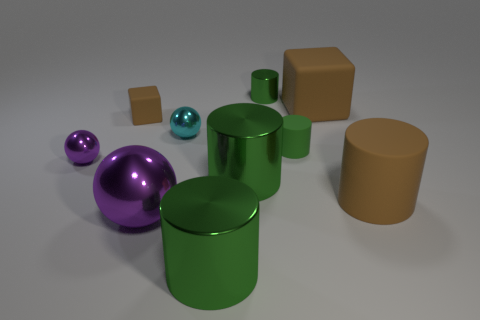How many green cylinders must be subtracted to get 1 green cylinders? 3 Subtract all gray cylinders. How many purple balls are left? 2 Subtract all small green cylinders. How many cylinders are left? 3 Subtract all brown cylinders. How many cylinders are left? 4 Subtract 1 spheres. How many spheres are left? 2 Subtract all blocks. How many objects are left? 8 Subtract all brown cylinders. Subtract all yellow balls. How many cylinders are left? 4 Subtract all tiny cyan things. Subtract all big green cylinders. How many objects are left? 7 Add 8 tiny cyan metal spheres. How many tiny cyan metal spheres are left? 9 Add 5 cyan metal balls. How many cyan metal balls exist? 6 